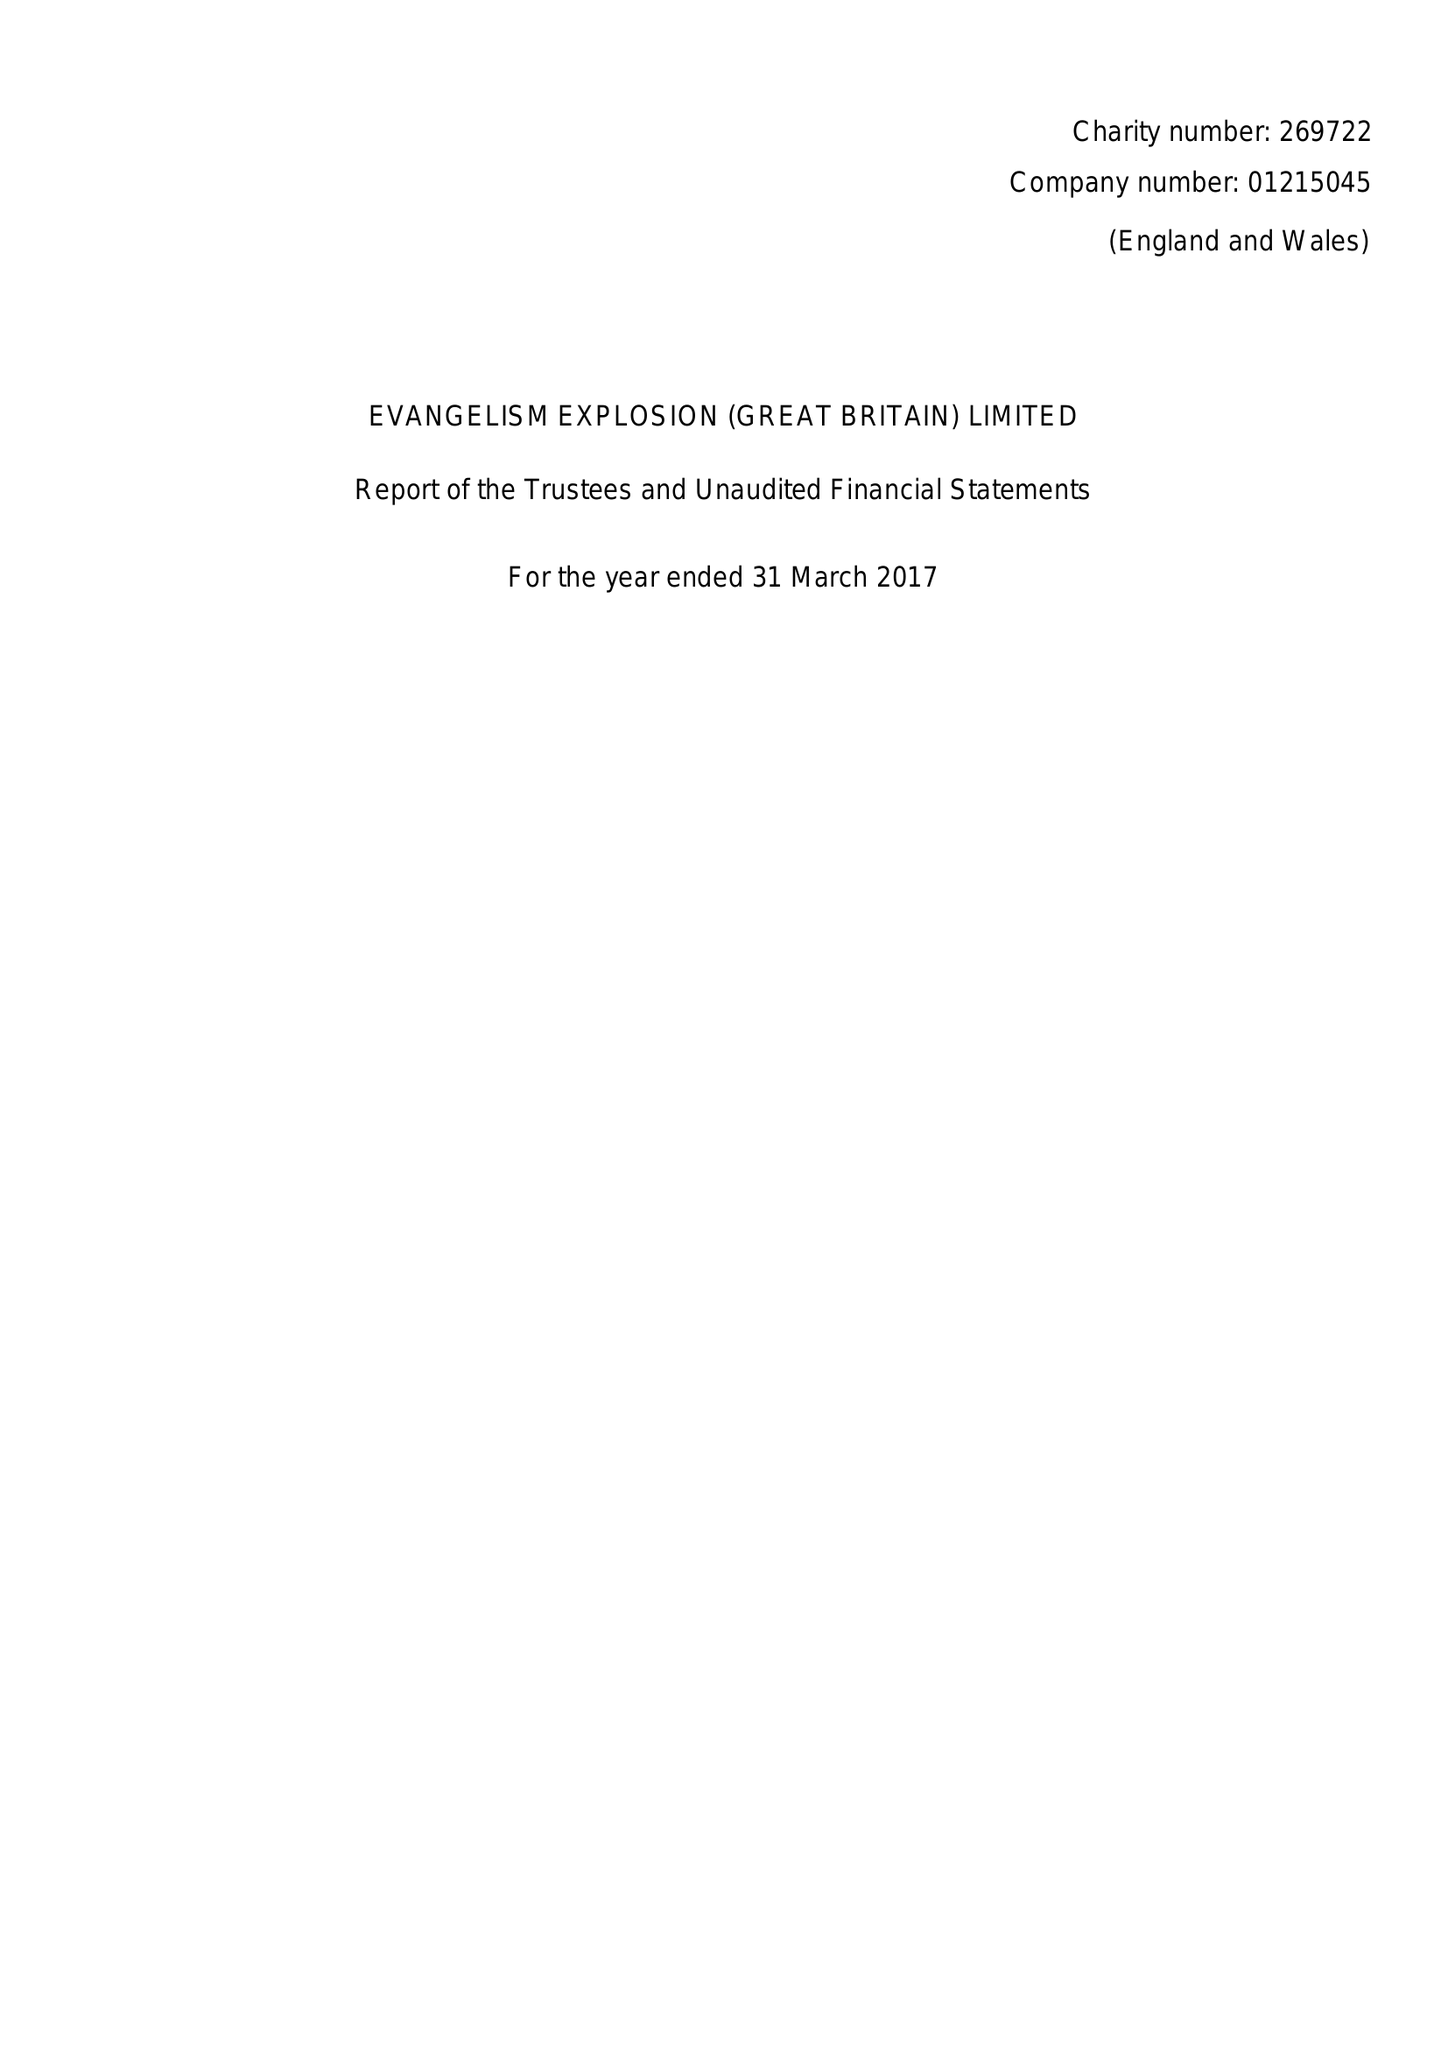What is the value for the address__postcode?
Answer the question using a single word or phrase. CV21 4PP 